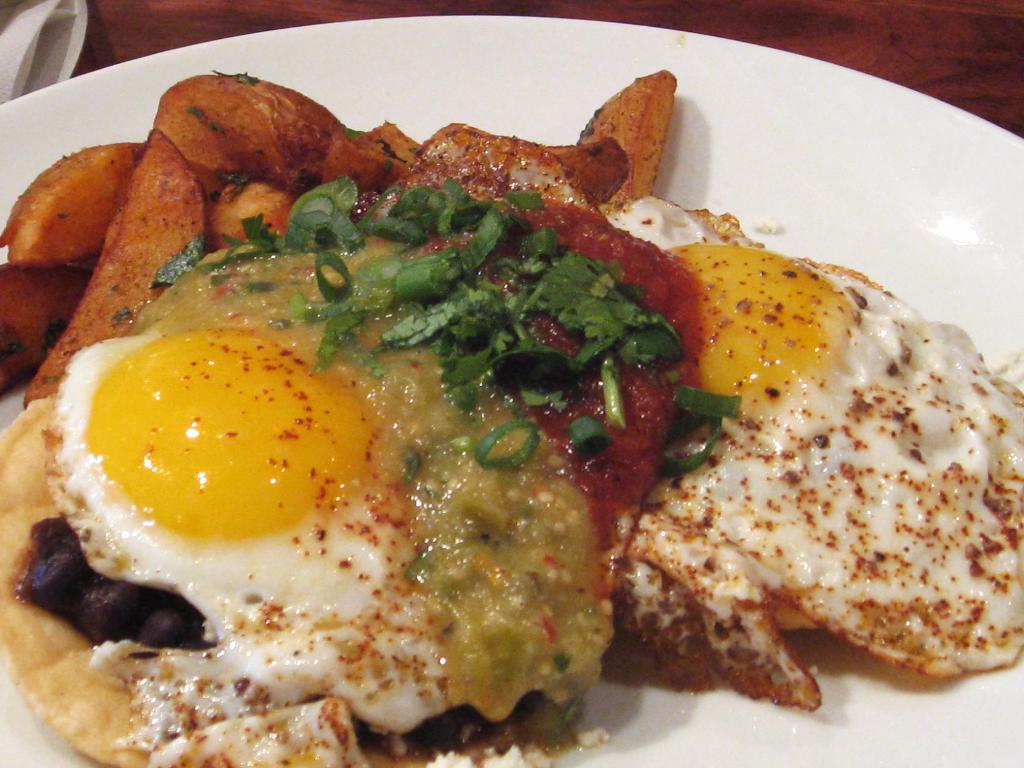What object is located at the bottom of the image? There is a plate at the bottom of the image. What is on the plate? There are food items on the plate. What type of voyage is depicted in the image? There is no voyage depicted in the image; it only shows a plate with food items. What form does the company take in the image? There is no company present in the image; it only shows a plate with food items. 